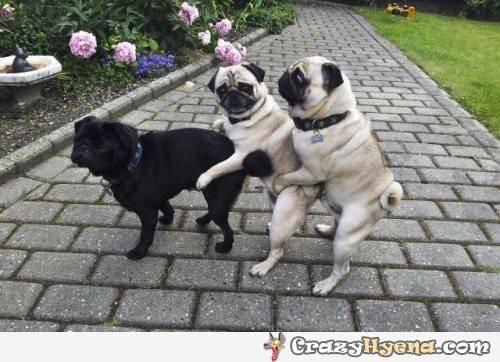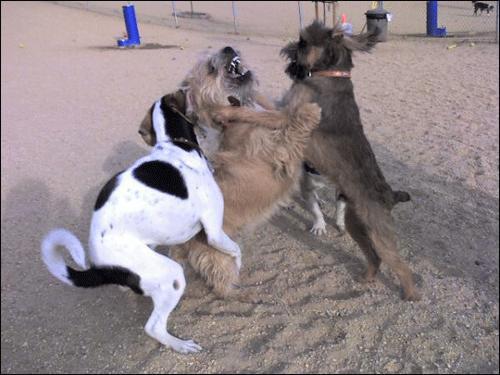The first image is the image on the left, the second image is the image on the right. Evaluate the accuracy of this statement regarding the images: "One image shows three pugs posed like a conga line, two of them facing another's back with front paws around its midsection.". Is it true? Answer yes or no. Yes. The first image is the image on the left, the second image is the image on the right. Considering the images on both sides, is "Three dogs are in a row, shoulder to shoulder in one of the images." valid? Answer yes or no. No. 